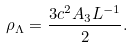Convert formula to latex. <formula><loc_0><loc_0><loc_500><loc_500>\rho _ { \Lambda } = \frac { 3 c ^ { 2 } A _ { 3 } L ^ { - 1 } } { 2 } .</formula> 